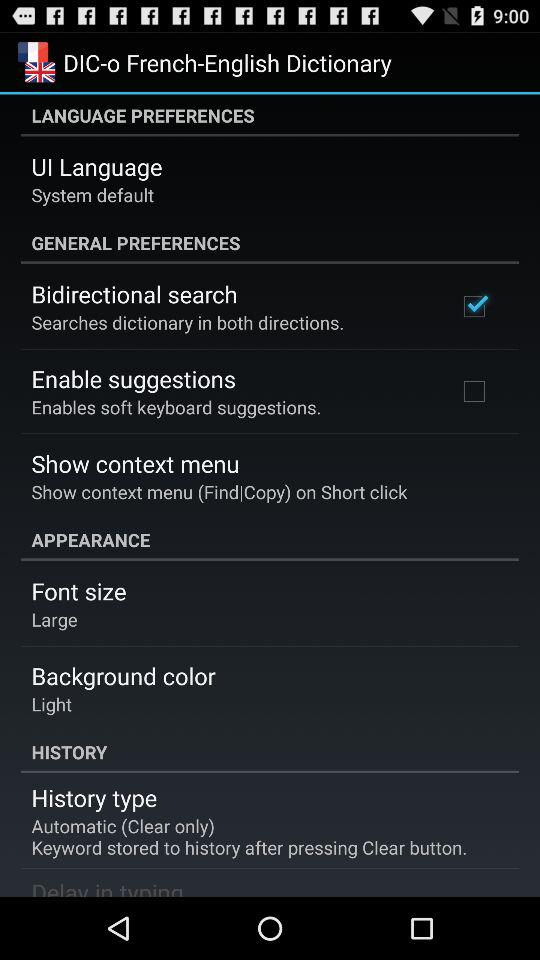What is the "UI Language"? The "UI Language" is "System default". 